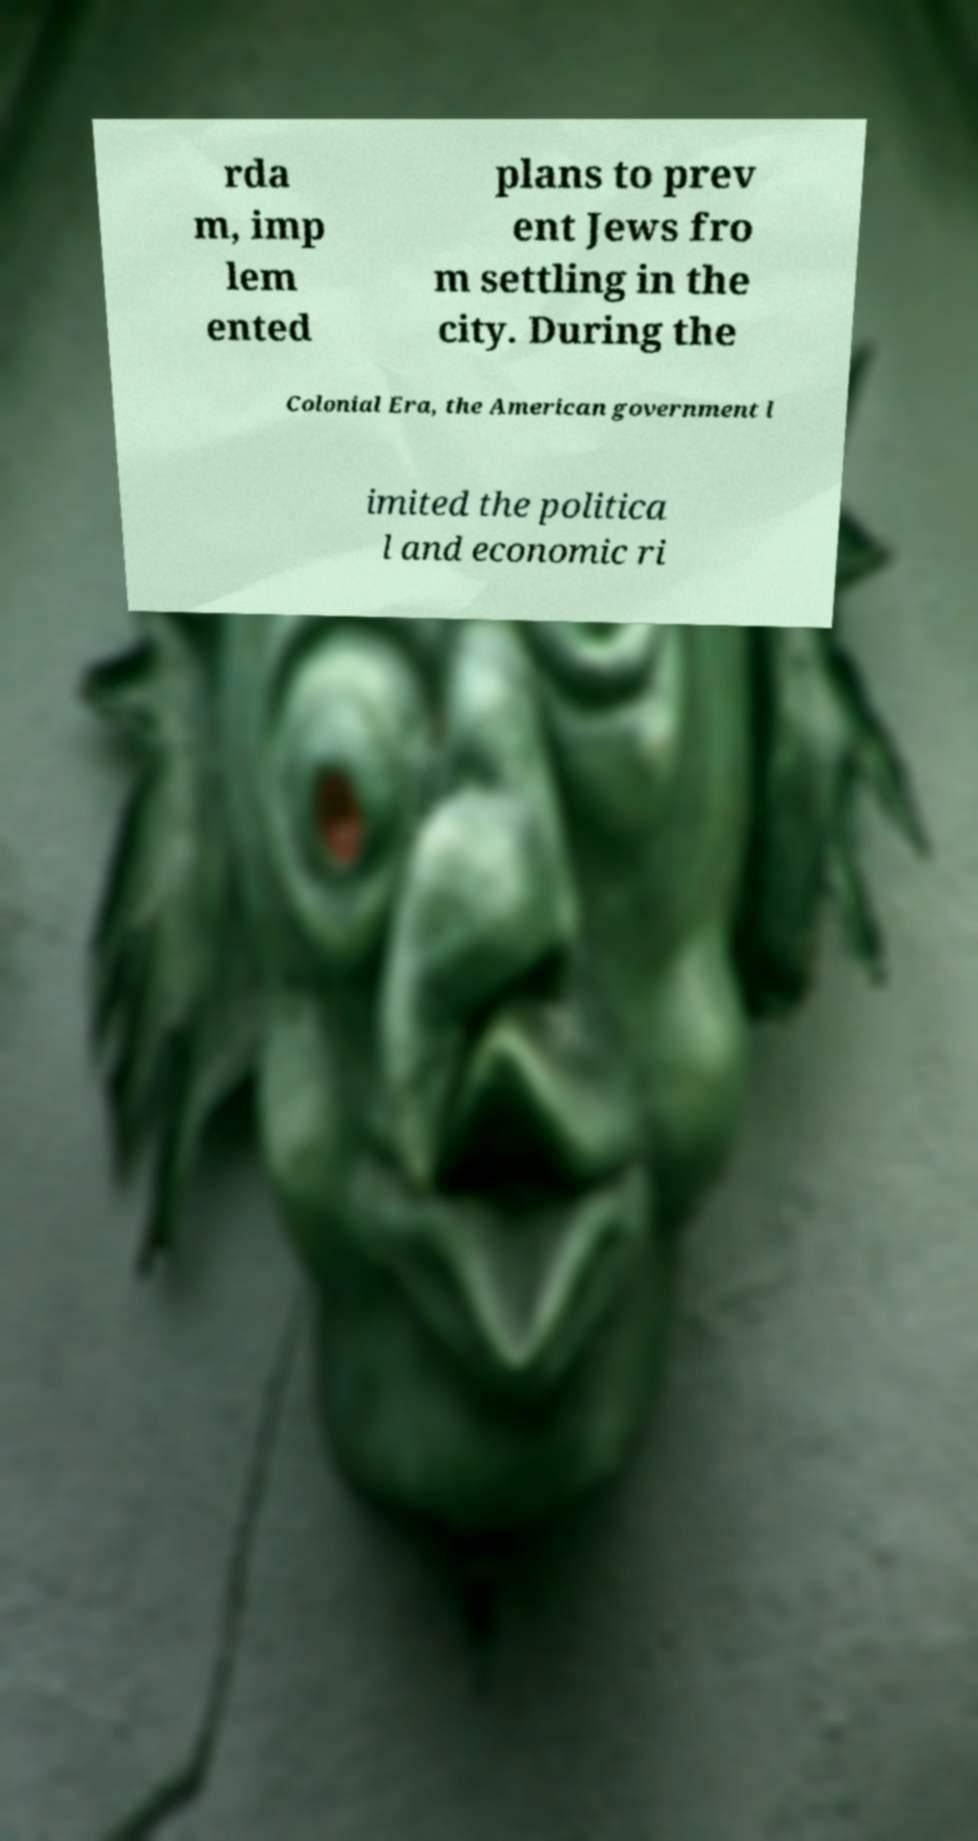I need the written content from this picture converted into text. Can you do that? rda m, imp lem ented plans to prev ent Jews fro m settling in the city. During the Colonial Era, the American government l imited the politica l and economic ri 